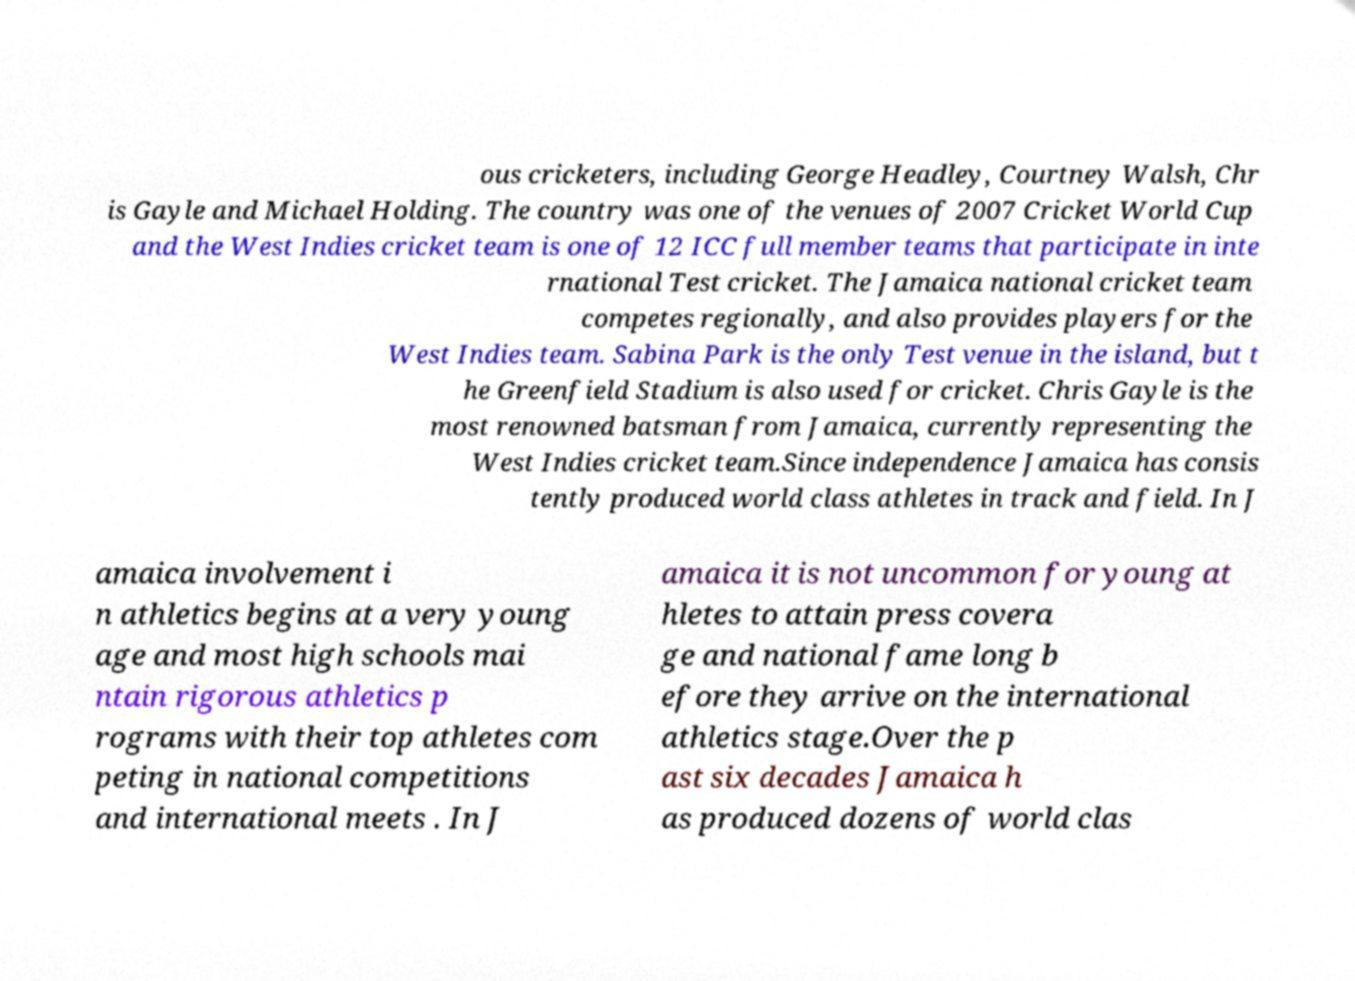There's text embedded in this image that I need extracted. Can you transcribe it verbatim? ous cricketers, including George Headley, Courtney Walsh, Chr is Gayle and Michael Holding. The country was one of the venues of 2007 Cricket World Cup and the West Indies cricket team is one of 12 ICC full member teams that participate in inte rnational Test cricket. The Jamaica national cricket team competes regionally, and also provides players for the West Indies team. Sabina Park is the only Test venue in the island, but t he Greenfield Stadium is also used for cricket. Chris Gayle is the most renowned batsman from Jamaica, currently representing the West Indies cricket team.Since independence Jamaica has consis tently produced world class athletes in track and field. In J amaica involvement i n athletics begins at a very young age and most high schools mai ntain rigorous athletics p rograms with their top athletes com peting in national competitions and international meets . In J amaica it is not uncommon for young at hletes to attain press covera ge and national fame long b efore they arrive on the international athletics stage.Over the p ast six decades Jamaica h as produced dozens of world clas 